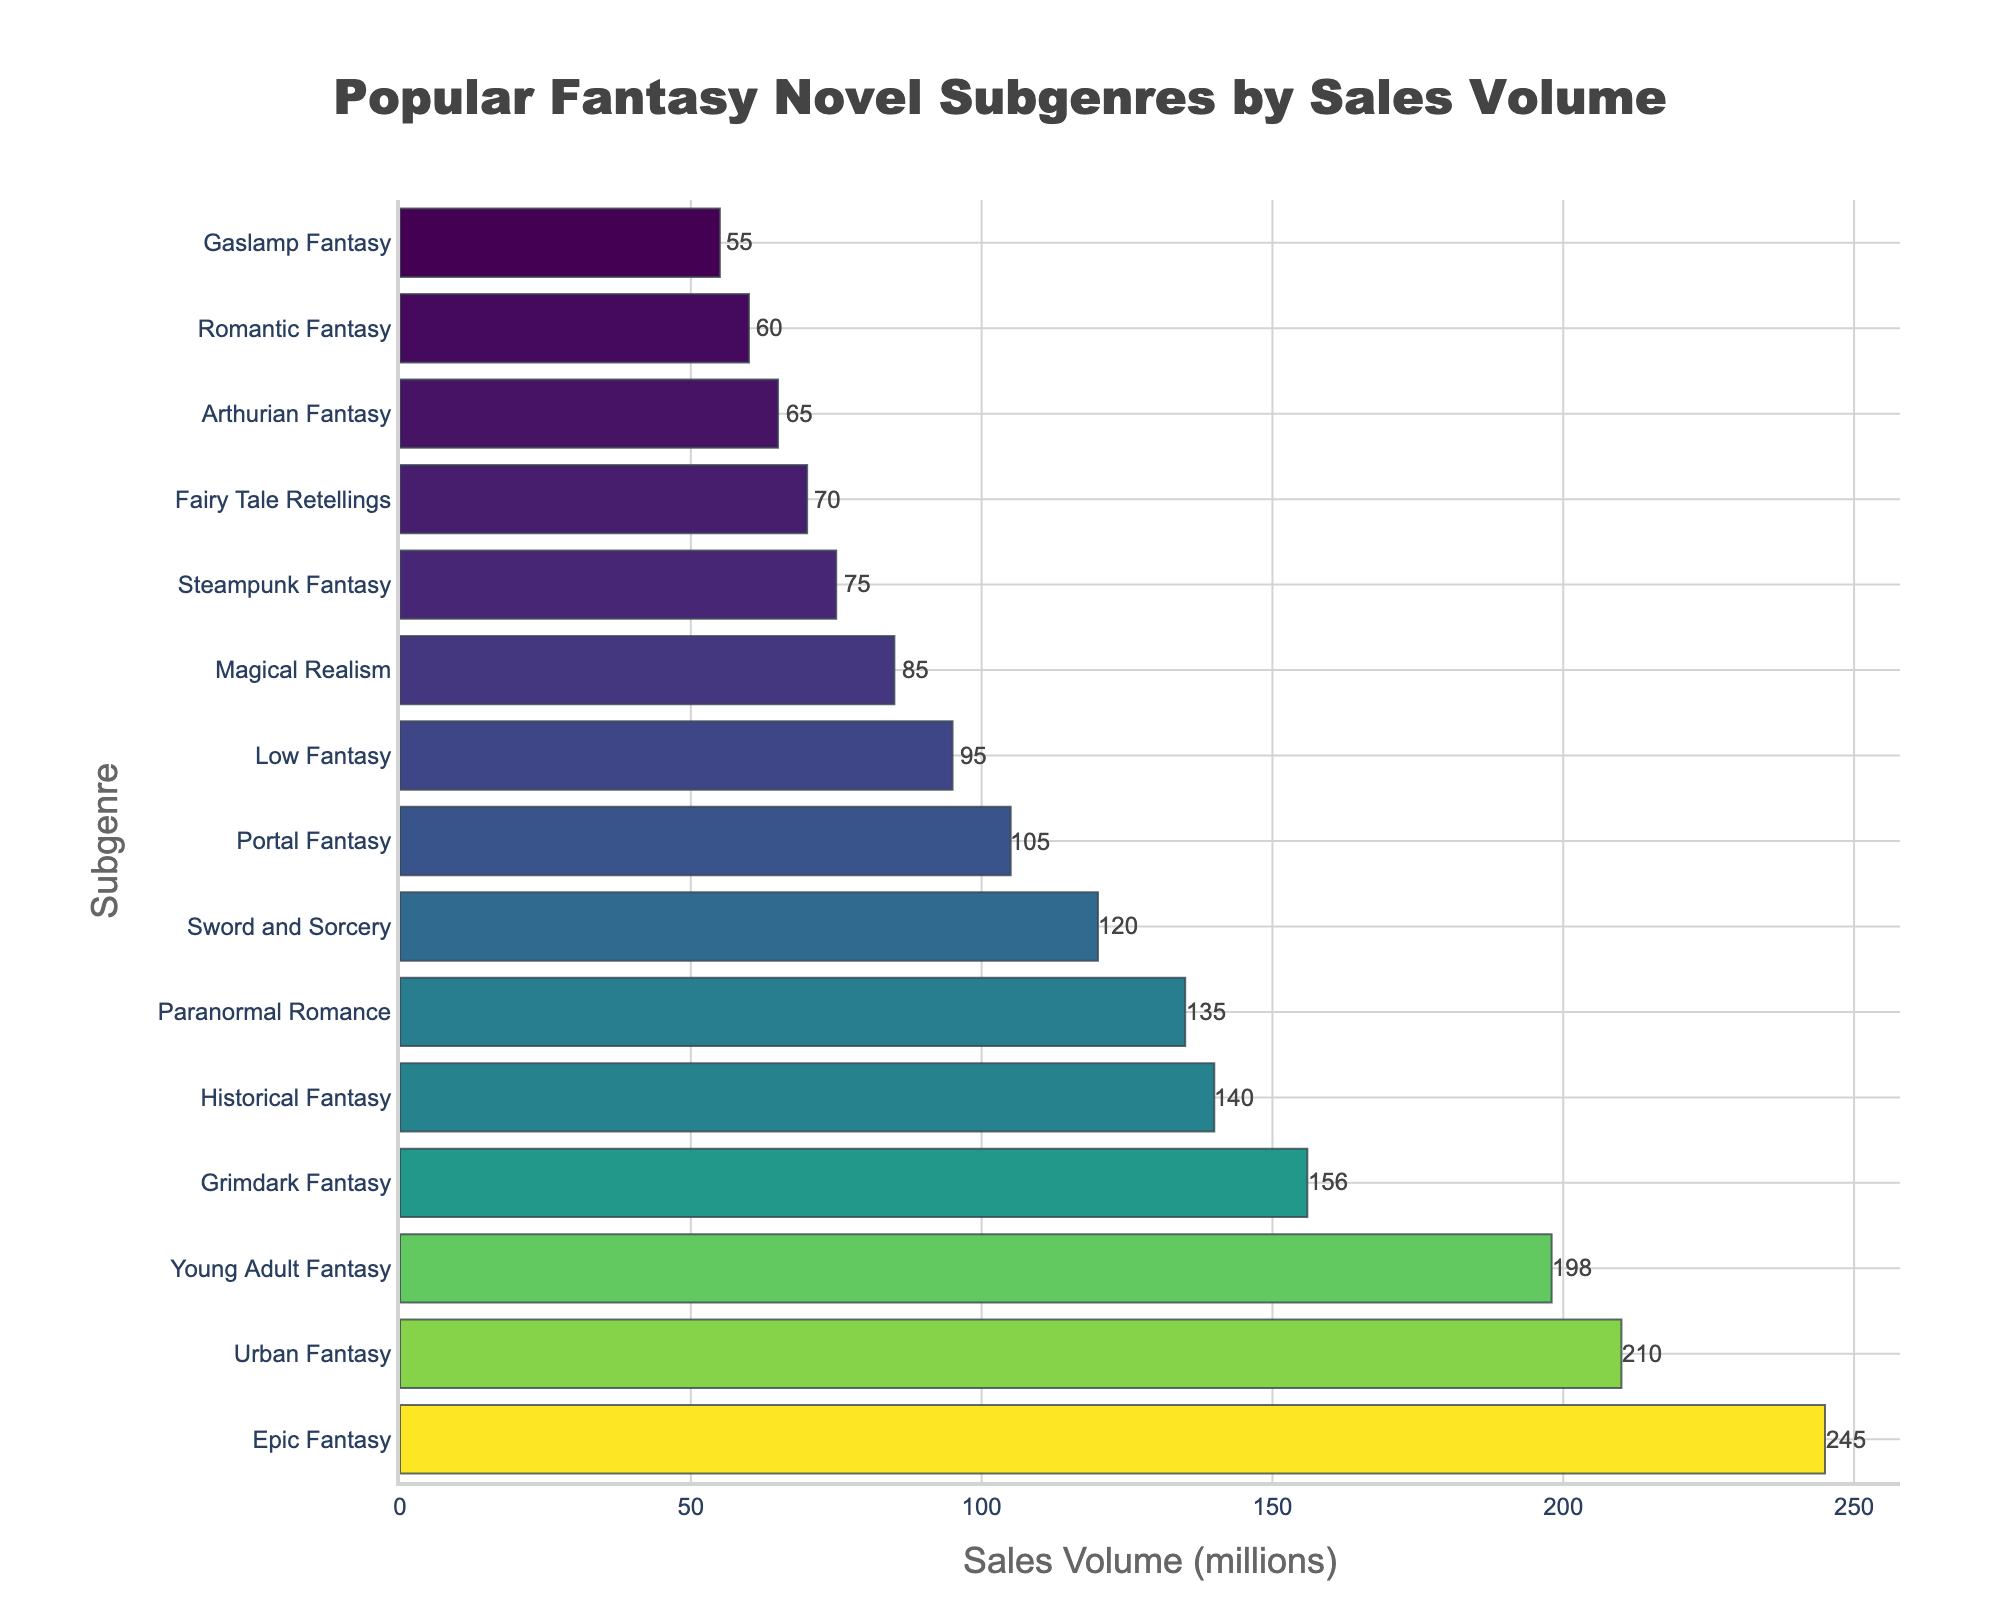Which subgenre has the highest sales volume? Locate the bar that extends the farthest to the right on the chart. This bar represents the subgenre with the highest sales volume. The "Epic Fantasy" bar extends the furthest with a sales volume of 245 million.
Answer: Epic Fantasy Which subgenre has lower sales volume, Historical Fantasy or Paranormal Romance? Compare the lengths of the bars representing Historical Fantasy and Paranormal Romance. The bar for Historical Fantasy is longer, indicating a higher sales volume. Paranormal Romance has a lower sales volume of 135 million compared to Historical Fantasy's 140 million.
Answer: Paranormal Romance What is the difference in sales volume between Sword and Sorcery and Urban Fantasy? Identify the sales volumes for Sword and Sorcery (120 million) and Urban Fantasy (210 million). Subtract the smaller value from the larger one: 210 - 120 = 90.
Answer: 90 million What is the average sales volume of the top three subgenres? Find the sales volumes of the top three subgenres: Epic Fantasy (245 million), Urban Fantasy (210 million), and Young Adult Fantasy (198 million). Add these values: 245 + 210 + 198 = 653. Divide the sum by 3 to get the average: 653 / 3 ≈ 217.67.
Answer: 217.67 million Which subgenre has the smallest sales volume? Locate the bar that extends the least to the right. This bar represents the subgenre with the smallest sales volume. The "Gaslamp Fantasy" bar is the shortest with a sales volume of 55 million.
Answer: Gaslamp Fantasy How many subgenres have a sales volume greater than 150 million? Count the bars that extend past the 150 million mark on the x-axis. These bars represent subgenres with sales volumes greater than 150 million. There are four such bars: Epic Fantasy, Urban Fantasy, Young Adult Fantasy, and Grimdark Fantasy.
Answer: 4 Between Low Fantasy and Fairy Tale Retellings, which has a higher sales volume and by how much? Identify the sales volumes for Low Fantasy (95 million) and Fairy Tale Retellings (70 million). Calculate the difference by subtracting the smaller value from the larger: 95 - 70 = 25. Low Fantasy has a higher sales volume by 25 million.
Answer: Low Fantasy, by 25 million Which subgenres have sales volumes between 100 million and 200 million? Find the bars that end between 100 million and 200 million on the x-axis. These bars represent Portal Fantasy (105 million), Sword and Sorcery (120 million), Paranormal Romance (135 million), and Historical Fantasy (140 million).
Answer: Portal Fantasy, Sword and Sorcery, Paranormal Romance, Historical Fantasy What is the combined sales volume of the bottom five subgenres? Identify the sales volumes for the bottom five subgenres: Gaslamp Fantasy (55 million), Romantic Fantasy (60 million), Arthurian Fantasy (65 million), Fairy Tale Retellings (70 million), and Steampunk Fantasy (75 million). Sum these values: 55 + 60 + 65 + 70 + 75 = 325.
Answer: 325 million 